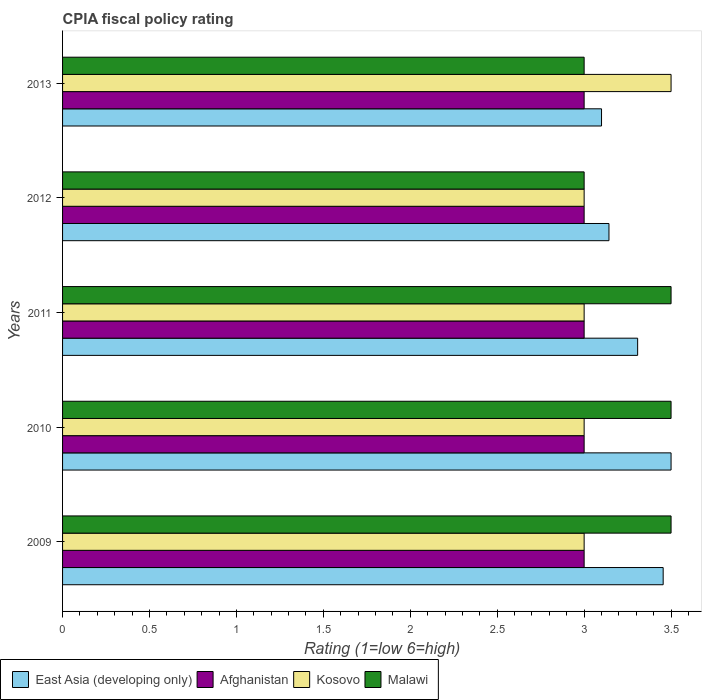How many different coloured bars are there?
Make the answer very short. 4. What is the label of the 4th group of bars from the top?
Make the answer very short. 2010. In how many cases, is the number of bars for a given year not equal to the number of legend labels?
Make the answer very short. 0. What is the CPIA rating in Afghanistan in 2012?
Your answer should be very brief. 3. Across all years, what is the maximum CPIA rating in East Asia (developing only)?
Make the answer very short. 3.5. Across all years, what is the minimum CPIA rating in Malawi?
Give a very brief answer. 3. In which year was the CPIA rating in Afghanistan maximum?
Offer a terse response. 2009. What is the difference between the CPIA rating in Afghanistan in 2009 and that in 2012?
Provide a succinct answer. 0. What is the difference between the CPIA rating in Kosovo in 2011 and the CPIA rating in Malawi in 2012?
Give a very brief answer. 0. What is the average CPIA rating in Malawi per year?
Your answer should be very brief. 3.3. In how many years, is the CPIA rating in Malawi greater than 2 ?
Your answer should be compact. 5. What is the ratio of the CPIA rating in East Asia (developing only) in 2010 to that in 2012?
Provide a succinct answer. 1.11. Is the CPIA rating in Afghanistan in 2010 less than that in 2013?
Your answer should be very brief. No. Is the difference between the CPIA rating in Afghanistan in 2009 and 2012 greater than the difference between the CPIA rating in East Asia (developing only) in 2009 and 2012?
Keep it short and to the point. No. What is the difference between the highest and the lowest CPIA rating in East Asia (developing only)?
Your answer should be compact. 0.4. Is it the case that in every year, the sum of the CPIA rating in Malawi and CPIA rating in Kosovo is greater than the sum of CPIA rating in Afghanistan and CPIA rating in East Asia (developing only)?
Offer a very short reply. No. What does the 1st bar from the top in 2010 represents?
Provide a short and direct response. Malawi. What does the 4th bar from the bottom in 2010 represents?
Your answer should be very brief. Malawi. Is it the case that in every year, the sum of the CPIA rating in East Asia (developing only) and CPIA rating in Malawi is greater than the CPIA rating in Kosovo?
Your response must be concise. Yes. How many bars are there?
Your answer should be very brief. 20. Where does the legend appear in the graph?
Offer a very short reply. Bottom left. How many legend labels are there?
Keep it short and to the point. 4. What is the title of the graph?
Your answer should be very brief. CPIA fiscal policy rating. What is the label or title of the X-axis?
Provide a short and direct response. Rating (1=low 6=high). What is the label or title of the Y-axis?
Offer a terse response. Years. What is the Rating (1=low 6=high) in East Asia (developing only) in 2009?
Provide a short and direct response. 3.45. What is the Rating (1=low 6=high) in Afghanistan in 2009?
Ensure brevity in your answer.  3. What is the Rating (1=low 6=high) in Kosovo in 2010?
Provide a short and direct response. 3. What is the Rating (1=low 6=high) in East Asia (developing only) in 2011?
Keep it short and to the point. 3.31. What is the Rating (1=low 6=high) of Kosovo in 2011?
Provide a succinct answer. 3. What is the Rating (1=low 6=high) in Malawi in 2011?
Ensure brevity in your answer.  3.5. What is the Rating (1=low 6=high) in East Asia (developing only) in 2012?
Provide a short and direct response. 3.14. What is the Rating (1=low 6=high) in Kosovo in 2012?
Keep it short and to the point. 3. What is the Rating (1=low 6=high) in Malawi in 2012?
Offer a terse response. 3. What is the Rating (1=low 6=high) of East Asia (developing only) in 2013?
Make the answer very short. 3.1. What is the Rating (1=low 6=high) of Afghanistan in 2013?
Provide a succinct answer. 3. What is the Rating (1=low 6=high) of Kosovo in 2013?
Your answer should be very brief. 3.5. Across all years, what is the maximum Rating (1=low 6=high) in East Asia (developing only)?
Offer a very short reply. 3.5. Across all years, what is the maximum Rating (1=low 6=high) in Afghanistan?
Ensure brevity in your answer.  3. Across all years, what is the minimum Rating (1=low 6=high) in Afghanistan?
Your answer should be very brief. 3. Across all years, what is the minimum Rating (1=low 6=high) of Malawi?
Give a very brief answer. 3. What is the total Rating (1=low 6=high) in East Asia (developing only) in the graph?
Give a very brief answer. 16.51. What is the total Rating (1=low 6=high) in Malawi in the graph?
Provide a short and direct response. 16.5. What is the difference between the Rating (1=low 6=high) of East Asia (developing only) in 2009 and that in 2010?
Provide a short and direct response. -0.05. What is the difference between the Rating (1=low 6=high) in Afghanistan in 2009 and that in 2010?
Give a very brief answer. 0. What is the difference between the Rating (1=low 6=high) of East Asia (developing only) in 2009 and that in 2011?
Offer a very short reply. 0.15. What is the difference between the Rating (1=low 6=high) of Malawi in 2009 and that in 2011?
Ensure brevity in your answer.  0. What is the difference between the Rating (1=low 6=high) of East Asia (developing only) in 2009 and that in 2012?
Your answer should be very brief. 0.31. What is the difference between the Rating (1=low 6=high) of Afghanistan in 2009 and that in 2012?
Offer a very short reply. 0. What is the difference between the Rating (1=low 6=high) in Kosovo in 2009 and that in 2012?
Offer a terse response. 0. What is the difference between the Rating (1=low 6=high) in East Asia (developing only) in 2009 and that in 2013?
Give a very brief answer. 0.35. What is the difference between the Rating (1=low 6=high) of East Asia (developing only) in 2010 and that in 2011?
Ensure brevity in your answer.  0.19. What is the difference between the Rating (1=low 6=high) in East Asia (developing only) in 2010 and that in 2012?
Your answer should be very brief. 0.36. What is the difference between the Rating (1=low 6=high) of Afghanistan in 2010 and that in 2012?
Offer a very short reply. 0. What is the difference between the Rating (1=low 6=high) in Kosovo in 2010 and that in 2012?
Your response must be concise. 0. What is the difference between the Rating (1=low 6=high) in East Asia (developing only) in 2010 and that in 2013?
Your answer should be very brief. 0.4. What is the difference between the Rating (1=low 6=high) in Afghanistan in 2010 and that in 2013?
Provide a short and direct response. 0. What is the difference between the Rating (1=low 6=high) in East Asia (developing only) in 2011 and that in 2012?
Make the answer very short. 0.16. What is the difference between the Rating (1=low 6=high) in Malawi in 2011 and that in 2012?
Give a very brief answer. 0.5. What is the difference between the Rating (1=low 6=high) in East Asia (developing only) in 2011 and that in 2013?
Keep it short and to the point. 0.21. What is the difference between the Rating (1=low 6=high) of Kosovo in 2011 and that in 2013?
Keep it short and to the point. -0.5. What is the difference between the Rating (1=low 6=high) of Malawi in 2011 and that in 2013?
Make the answer very short. 0.5. What is the difference between the Rating (1=low 6=high) in East Asia (developing only) in 2012 and that in 2013?
Provide a succinct answer. 0.04. What is the difference between the Rating (1=low 6=high) of Afghanistan in 2012 and that in 2013?
Provide a short and direct response. 0. What is the difference between the Rating (1=low 6=high) of Malawi in 2012 and that in 2013?
Keep it short and to the point. 0. What is the difference between the Rating (1=low 6=high) in East Asia (developing only) in 2009 and the Rating (1=low 6=high) in Afghanistan in 2010?
Your answer should be very brief. 0.45. What is the difference between the Rating (1=low 6=high) in East Asia (developing only) in 2009 and the Rating (1=low 6=high) in Kosovo in 2010?
Offer a very short reply. 0.45. What is the difference between the Rating (1=low 6=high) of East Asia (developing only) in 2009 and the Rating (1=low 6=high) of Malawi in 2010?
Your answer should be very brief. -0.05. What is the difference between the Rating (1=low 6=high) of Afghanistan in 2009 and the Rating (1=low 6=high) of Kosovo in 2010?
Keep it short and to the point. 0. What is the difference between the Rating (1=low 6=high) in East Asia (developing only) in 2009 and the Rating (1=low 6=high) in Afghanistan in 2011?
Make the answer very short. 0.45. What is the difference between the Rating (1=low 6=high) in East Asia (developing only) in 2009 and the Rating (1=low 6=high) in Kosovo in 2011?
Offer a very short reply. 0.45. What is the difference between the Rating (1=low 6=high) in East Asia (developing only) in 2009 and the Rating (1=low 6=high) in Malawi in 2011?
Give a very brief answer. -0.05. What is the difference between the Rating (1=low 6=high) in Afghanistan in 2009 and the Rating (1=low 6=high) in Kosovo in 2011?
Offer a terse response. 0. What is the difference between the Rating (1=low 6=high) of Afghanistan in 2009 and the Rating (1=low 6=high) of Malawi in 2011?
Your answer should be very brief. -0.5. What is the difference between the Rating (1=low 6=high) in East Asia (developing only) in 2009 and the Rating (1=low 6=high) in Afghanistan in 2012?
Make the answer very short. 0.45. What is the difference between the Rating (1=low 6=high) in East Asia (developing only) in 2009 and the Rating (1=low 6=high) in Kosovo in 2012?
Keep it short and to the point. 0.45. What is the difference between the Rating (1=low 6=high) in East Asia (developing only) in 2009 and the Rating (1=low 6=high) in Malawi in 2012?
Offer a terse response. 0.45. What is the difference between the Rating (1=low 6=high) of East Asia (developing only) in 2009 and the Rating (1=low 6=high) of Afghanistan in 2013?
Make the answer very short. 0.45. What is the difference between the Rating (1=low 6=high) in East Asia (developing only) in 2009 and the Rating (1=low 6=high) in Kosovo in 2013?
Your answer should be compact. -0.05. What is the difference between the Rating (1=low 6=high) in East Asia (developing only) in 2009 and the Rating (1=low 6=high) in Malawi in 2013?
Give a very brief answer. 0.45. What is the difference between the Rating (1=low 6=high) of East Asia (developing only) in 2010 and the Rating (1=low 6=high) of Afghanistan in 2011?
Give a very brief answer. 0.5. What is the difference between the Rating (1=low 6=high) in East Asia (developing only) in 2010 and the Rating (1=low 6=high) in Malawi in 2011?
Offer a very short reply. 0. What is the difference between the Rating (1=low 6=high) in Afghanistan in 2010 and the Rating (1=low 6=high) in Malawi in 2011?
Provide a succinct answer. -0.5. What is the difference between the Rating (1=low 6=high) of Kosovo in 2010 and the Rating (1=low 6=high) of Malawi in 2011?
Give a very brief answer. -0.5. What is the difference between the Rating (1=low 6=high) of East Asia (developing only) in 2010 and the Rating (1=low 6=high) of Afghanistan in 2013?
Make the answer very short. 0.5. What is the difference between the Rating (1=low 6=high) of Afghanistan in 2010 and the Rating (1=low 6=high) of Kosovo in 2013?
Offer a terse response. -0.5. What is the difference between the Rating (1=low 6=high) of East Asia (developing only) in 2011 and the Rating (1=low 6=high) of Afghanistan in 2012?
Make the answer very short. 0.31. What is the difference between the Rating (1=low 6=high) in East Asia (developing only) in 2011 and the Rating (1=low 6=high) in Kosovo in 2012?
Your answer should be compact. 0.31. What is the difference between the Rating (1=low 6=high) of East Asia (developing only) in 2011 and the Rating (1=low 6=high) of Malawi in 2012?
Provide a short and direct response. 0.31. What is the difference between the Rating (1=low 6=high) in Afghanistan in 2011 and the Rating (1=low 6=high) in Kosovo in 2012?
Make the answer very short. 0. What is the difference between the Rating (1=low 6=high) in Afghanistan in 2011 and the Rating (1=low 6=high) in Malawi in 2012?
Keep it short and to the point. 0. What is the difference between the Rating (1=low 6=high) in East Asia (developing only) in 2011 and the Rating (1=low 6=high) in Afghanistan in 2013?
Your answer should be very brief. 0.31. What is the difference between the Rating (1=low 6=high) in East Asia (developing only) in 2011 and the Rating (1=low 6=high) in Kosovo in 2013?
Provide a short and direct response. -0.19. What is the difference between the Rating (1=low 6=high) in East Asia (developing only) in 2011 and the Rating (1=low 6=high) in Malawi in 2013?
Make the answer very short. 0.31. What is the difference between the Rating (1=low 6=high) of East Asia (developing only) in 2012 and the Rating (1=low 6=high) of Afghanistan in 2013?
Give a very brief answer. 0.14. What is the difference between the Rating (1=low 6=high) of East Asia (developing only) in 2012 and the Rating (1=low 6=high) of Kosovo in 2013?
Provide a short and direct response. -0.36. What is the difference between the Rating (1=low 6=high) of East Asia (developing only) in 2012 and the Rating (1=low 6=high) of Malawi in 2013?
Your answer should be very brief. 0.14. What is the difference between the Rating (1=low 6=high) in Afghanistan in 2012 and the Rating (1=low 6=high) in Malawi in 2013?
Keep it short and to the point. 0. What is the difference between the Rating (1=low 6=high) in Kosovo in 2012 and the Rating (1=low 6=high) in Malawi in 2013?
Provide a short and direct response. 0. What is the average Rating (1=low 6=high) of East Asia (developing only) per year?
Your answer should be very brief. 3.3. What is the average Rating (1=low 6=high) of Afghanistan per year?
Give a very brief answer. 3. In the year 2009, what is the difference between the Rating (1=low 6=high) in East Asia (developing only) and Rating (1=low 6=high) in Afghanistan?
Make the answer very short. 0.45. In the year 2009, what is the difference between the Rating (1=low 6=high) of East Asia (developing only) and Rating (1=low 6=high) of Kosovo?
Your response must be concise. 0.45. In the year 2009, what is the difference between the Rating (1=low 6=high) in East Asia (developing only) and Rating (1=low 6=high) in Malawi?
Offer a very short reply. -0.05. In the year 2009, what is the difference between the Rating (1=low 6=high) of Afghanistan and Rating (1=low 6=high) of Kosovo?
Your response must be concise. 0. In the year 2009, what is the difference between the Rating (1=low 6=high) in Kosovo and Rating (1=low 6=high) in Malawi?
Offer a very short reply. -0.5. In the year 2010, what is the difference between the Rating (1=low 6=high) in East Asia (developing only) and Rating (1=low 6=high) in Afghanistan?
Your answer should be compact. 0.5. In the year 2010, what is the difference between the Rating (1=low 6=high) of East Asia (developing only) and Rating (1=low 6=high) of Kosovo?
Your answer should be very brief. 0.5. In the year 2010, what is the difference between the Rating (1=low 6=high) in Afghanistan and Rating (1=low 6=high) in Kosovo?
Offer a very short reply. 0. In the year 2010, what is the difference between the Rating (1=low 6=high) in Afghanistan and Rating (1=low 6=high) in Malawi?
Offer a very short reply. -0.5. In the year 2010, what is the difference between the Rating (1=low 6=high) in Kosovo and Rating (1=low 6=high) in Malawi?
Provide a short and direct response. -0.5. In the year 2011, what is the difference between the Rating (1=low 6=high) of East Asia (developing only) and Rating (1=low 6=high) of Afghanistan?
Ensure brevity in your answer.  0.31. In the year 2011, what is the difference between the Rating (1=low 6=high) of East Asia (developing only) and Rating (1=low 6=high) of Kosovo?
Make the answer very short. 0.31. In the year 2011, what is the difference between the Rating (1=low 6=high) of East Asia (developing only) and Rating (1=low 6=high) of Malawi?
Offer a very short reply. -0.19. In the year 2011, what is the difference between the Rating (1=low 6=high) in Afghanistan and Rating (1=low 6=high) in Kosovo?
Provide a succinct answer. 0. In the year 2011, what is the difference between the Rating (1=low 6=high) of Afghanistan and Rating (1=low 6=high) of Malawi?
Your answer should be compact. -0.5. In the year 2011, what is the difference between the Rating (1=low 6=high) in Kosovo and Rating (1=low 6=high) in Malawi?
Make the answer very short. -0.5. In the year 2012, what is the difference between the Rating (1=low 6=high) of East Asia (developing only) and Rating (1=low 6=high) of Afghanistan?
Your answer should be compact. 0.14. In the year 2012, what is the difference between the Rating (1=low 6=high) of East Asia (developing only) and Rating (1=low 6=high) of Kosovo?
Give a very brief answer. 0.14. In the year 2012, what is the difference between the Rating (1=low 6=high) in East Asia (developing only) and Rating (1=low 6=high) in Malawi?
Give a very brief answer. 0.14. In the year 2012, what is the difference between the Rating (1=low 6=high) in Afghanistan and Rating (1=low 6=high) in Kosovo?
Make the answer very short. 0. In the year 2012, what is the difference between the Rating (1=low 6=high) of Afghanistan and Rating (1=low 6=high) of Malawi?
Your answer should be compact. 0. In the year 2013, what is the difference between the Rating (1=low 6=high) of East Asia (developing only) and Rating (1=low 6=high) of Kosovo?
Ensure brevity in your answer.  -0.4. In the year 2013, what is the difference between the Rating (1=low 6=high) in Afghanistan and Rating (1=low 6=high) in Kosovo?
Offer a terse response. -0.5. In the year 2013, what is the difference between the Rating (1=low 6=high) of Afghanistan and Rating (1=low 6=high) of Malawi?
Provide a short and direct response. 0. In the year 2013, what is the difference between the Rating (1=low 6=high) in Kosovo and Rating (1=low 6=high) in Malawi?
Your response must be concise. 0.5. What is the ratio of the Rating (1=low 6=high) of East Asia (developing only) in 2009 to that in 2011?
Your response must be concise. 1.04. What is the ratio of the Rating (1=low 6=high) of Afghanistan in 2009 to that in 2011?
Keep it short and to the point. 1. What is the ratio of the Rating (1=low 6=high) of Malawi in 2009 to that in 2011?
Provide a short and direct response. 1. What is the ratio of the Rating (1=low 6=high) of East Asia (developing only) in 2009 to that in 2012?
Ensure brevity in your answer.  1.1. What is the ratio of the Rating (1=low 6=high) of Kosovo in 2009 to that in 2012?
Provide a succinct answer. 1. What is the ratio of the Rating (1=low 6=high) of East Asia (developing only) in 2009 to that in 2013?
Make the answer very short. 1.11. What is the ratio of the Rating (1=low 6=high) of Afghanistan in 2009 to that in 2013?
Offer a very short reply. 1. What is the ratio of the Rating (1=low 6=high) of Kosovo in 2009 to that in 2013?
Ensure brevity in your answer.  0.86. What is the ratio of the Rating (1=low 6=high) of East Asia (developing only) in 2010 to that in 2011?
Your answer should be very brief. 1.06. What is the ratio of the Rating (1=low 6=high) of Afghanistan in 2010 to that in 2011?
Your response must be concise. 1. What is the ratio of the Rating (1=low 6=high) in Kosovo in 2010 to that in 2011?
Provide a short and direct response. 1. What is the ratio of the Rating (1=low 6=high) in Malawi in 2010 to that in 2011?
Give a very brief answer. 1. What is the ratio of the Rating (1=low 6=high) of East Asia (developing only) in 2010 to that in 2012?
Your answer should be compact. 1.11. What is the ratio of the Rating (1=low 6=high) in Afghanistan in 2010 to that in 2012?
Keep it short and to the point. 1. What is the ratio of the Rating (1=low 6=high) in East Asia (developing only) in 2010 to that in 2013?
Keep it short and to the point. 1.13. What is the ratio of the Rating (1=low 6=high) of Afghanistan in 2010 to that in 2013?
Make the answer very short. 1. What is the ratio of the Rating (1=low 6=high) of Kosovo in 2010 to that in 2013?
Provide a short and direct response. 0.86. What is the ratio of the Rating (1=low 6=high) of East Asia (developing only) in 2011 to that in 2012?
Your response must be concise. 1.05. What is the ratio of the Rating (1=low 6=high) of Afghanistan in 2011 to that in 2012?
Provide a succinct answer. 1. What is the ratio of the Rating (1=low 6=high) of Kosovo in 2011 to that in 2012?
Provide a short and direct response. 1. What is the ratio of the Rating (1=low 6=high) in Malawi in 2011 to that in 2012?
Give a very brief answer. 1.17. What is the ratio of the Rating (1=low 6=high) in East Asia (developing only) in 2011 to that in 2013?
Your answer should be very brief. 1.07. What is the ratio of the Rating (1=low 6=high) of Kosovo in 2011 to that in 2013?
Provide a succinct answer. 0.86. What is the ratio of the Rating (1=low 6=high) of Malawi in 2011 to that in 2013?
Offer a terse response. 1.17. What is the ratio of the Rating (1=low 6=high) in East Asia (developing only) in 2012 to that in 2013?
Your response must be concise. 1.01. What is the ratio of the Rating (1=low 6=high) of Afghanistan in 2012 to that in 2013?
Give a very brief answer. 1. What is the difference between the highest and the second highest Rating (1=low 6=high) of East Asia (developing only)?
Your answer should be compact. 0.05. What is the difference between the highest and the second highest Rating (1=low 6=high) of Afghanistan?
Provide a short and direct response. 0. What is the difference between the highest and the second highest Rating (1=low 6=high) in Kosovo?
Your answer should be very brief. 0.5. What is the difference between the highest and the second highest Rating (1=low 6=high) of Malawi?
Your answer should be very brief. 0. What is the difference between the highest and the lowest Rating (1=low 6=high) in East Asia (developing only)?
Your response must be concise. 0.4. What is the difference between the highest and the lowest Rating (1=low 6=high) in Kosovo?
Provide a succinct answer. 0.5. What is the difference between the highest and the lowest Rating (1=low 6=high) in Malawi?
Your response must be concise. 0.5. 